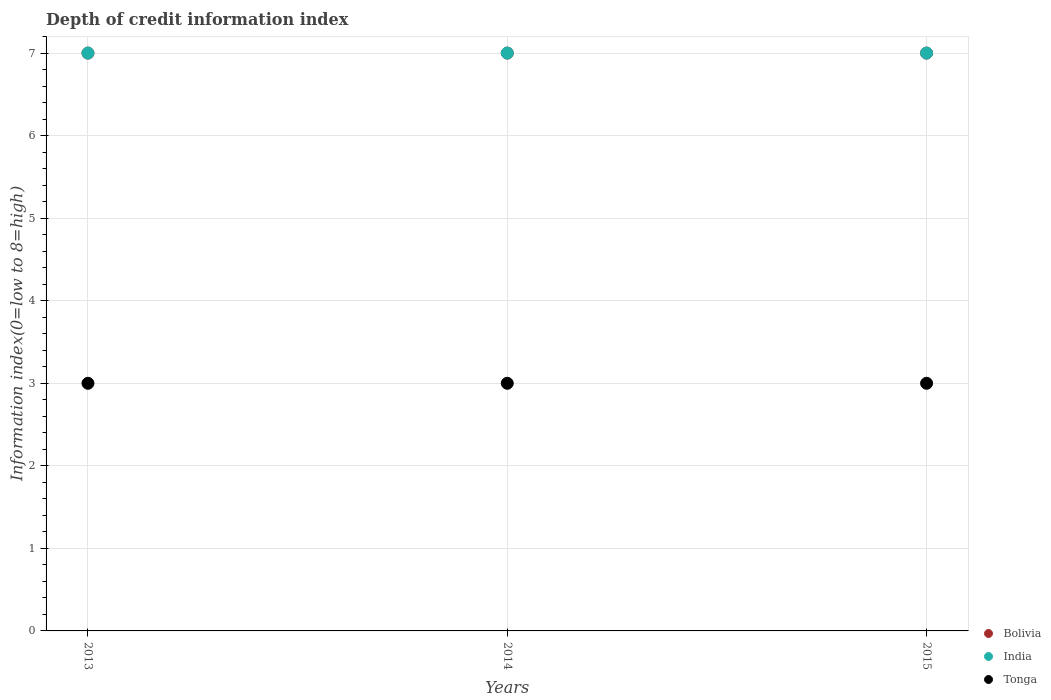How many different coloured dotlines are there?
Your answer should be very brief. 3. Is the number of dotlines equal to the number of legend labels?
Give a very brief answer. Yes. What is the information index in India in 2014?
Keep it short and to the point. 7. Across all years, what is the maximum information index in Tonga?
Make the answer very short. 3. Across all years, what is the minimum information index in Tonga?
Give a very brief answer. 3. In which year was the information index in India minimum?
Make the answer very short. 2013. What is the total information index in Bolivia in the graph?
Provide a succinct answer. 21. What is the difference between the information index in India in 2015 and the information index in Tonga in 2013?
Offer a very short reply. 4. Is the information index in India in 2013 less than that in 2014?
Make the answer very short. No. What is the difference between the highest and the second highest information index in Tonga?
Offer a terse response. 0. What is the difference between the highest and the lowest information index in Tonga?
Your response must be concise. 0. Is it the case that in every year, the sum of the information index in Bolivia and information index in Tonga  is greater than the information index in India?
Keep it short and to the point. Yes. Does the information index in India monotonically increase over the years?
Your answer should be compact. No. Is the information index in Tonga strictly greater than the information index in Bolivia over the years?
Ensure brevity in your answer.  No. How many dotlines are there?
Your response must be concise. 3. How many years are there in the graph?
Provide a succinct answer. 3. Are the values on the major ticks of Y-axis written in scientific E-notation?
Provide a short and direct response. No. Where does the legend appear in the graph?
Your answer should be compact. Bottom right. How many legend labels are there?
Offer a terse response. 3. What is the title of the graph?
Ensure brevity in your answer.  Depth of credit information index. Does "Solomon Islands" appear as one of the legend labels in the graph?
Ensure brevity in your answer.  No. What is the label or title of the X-axis?
Provide a succinct answer. Years. What is the label or title of the Y-axis?
Keep it short and to the point. Information index(0=low to 8=high). What is the Information index(0=low to 8=high) in India in 2013?
Give a very brief answer. 7. What is the Information index(0=low to 8=high) in Bolivia in 2014?
Your response must be concise. 7. What is the Information index(0=low to 8=high) of India in 2014?
Give a very brief answer. 7. What is the Information index(0=low to 8=high) of India in 2015?
Your answer should be very brief. 7. Across all years, what is the maximum Information index(0=low to 8=high) in Bolivia?
Offer a very short reply. 7. Across all years, what is the maximum Information index(0=low to 8=high) of India?
Your response must be concise. 7. What is the difference between the Information index(0=low to 8=high) in Bolivia in 2013 and that in 2014?
Offer a terse response. 0. What is the difference between the Information index(0=low to 8=high) in India in 2013 and that in 2014?
Your response must be concise. 0. What is the difference between the Information index(0=low to 8=high) in Tonga in 2013 and that in 2015?
Provide a short and direct response. 0. What is the difference between the Information index(0=low to 8=high) in Bolivia in 2013 and the Information index(0=low to 8=high) in Tonga in 2014?
Keep it short and to the point. 4. What is the difference between the Information index(0=low to 8=high) of Bolivia in 2013 and the Information index(0=low to 8=high) of Tonga in 2015?
Provide a short and direct response. 4. What is the difference between the Information index(0=low to 8=high) of India in 2013 and the Information index(0=low to 8=high) of Tonga in 2015?
Offer a terse response. 4. What is the difference between the Information index(0=low to 8=high) in Bolivia in 2014 and the Information index(0=low to 8=high) in Tonga in 2015?
Your answer should be compact. 4. What is the difference between the Information index(0=low to 8=high) of India in 2014 and the Information index(0=low to 8=high) of Tonga in 2015?
Your response must be concise. 4. What is the average Information index(0=low to 8=high) in Bolivia per year?
Offer a very short reply. 7. What is the average Information index(0=low to 8=high) of India per year?
Ensure brevity in your answer.  7. What is the average Information index(0=low to 8=high) of Tonga per year?
Ensure brevity in your answer.  3. In the year 2013, what is the difference between the Information index(0=low to 8=high) in India and Information index(0=low to 8=high) in Tonga?
Keep it short and to the point. 4. In the year 2014, what is the difference between the Information index(0=low to 8=high) of Bolivia and Information index(0=low to 8=high) of Tonga?
Your answer should be very brief. 4. In the year 2014, what is the difference between the Information index(0=low to 8=high) in India and Information index(0=low to 8=high) in Tonga?
Your response must be concise. 4. In the year 2015, what is the difference between the Information index(0=low to 8=high) in India and Information index(0=low to 8=high) in Tonga?
Offer a very short reply. 4. What is the ratio of the Information index(0=low to 8=high) in Tonga in 2013 to that in 2014?
Your response must be concise. 1. What is the ratio of the Information index(0=low to 8=high) of Bolivia in 2013 to that in 2015?
Your answer should be very brief. 1. What is the ratio of the Information index(0=low to 8=high) in India in 2013 to that in 2015?
Ensure brevity in your answer.  1. What is the ratio of the Information index(0=low to 8=high) in Tonga in 2013 to that in 2015?
Provide a succinct answer. 1. What is the ratio of the Information index(0=low to 8=high) of Bolivia in 2014 to that in 2015?
Offer a terse response. 1. What is the ratio of the Information index(0=low to 8=high) of India in 2014 to that in 2015?
Keep it short and to the point. 1. What is the difference between the highest and the second highest Information index(0=low to 8=high) in Tonga?
Offer a very short reply. 0. What is the difference between the highest and the lowest Information index(0=low to 8=high) of Bolivia?
Keep it short and to the point. 0. 